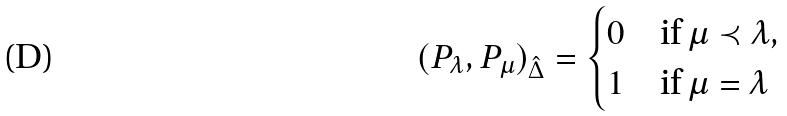Convert formula to latex. <formula><loc_0><loc_0><loc_500><loc_500>( P _ { \lambda } , P _ { \mu } ) _ { \hat { \Delta } } = \begin{cases} 0 & \text {if} \, \mu \prec \lambda , \\ 1 & \text {if} \, \mu = \lambda \end{cases}</formula> 